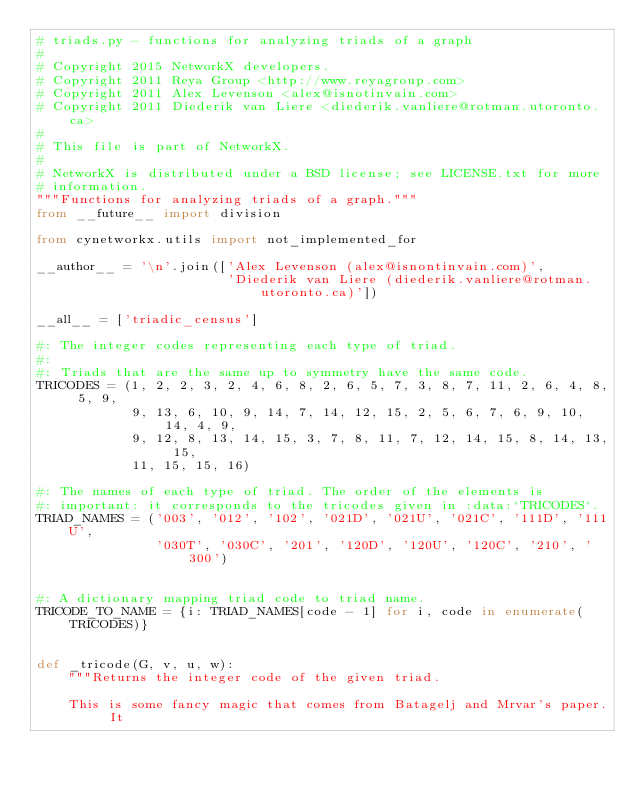<code> <loc_0><loc_0><loc_500><loc_500><_Python_># triads.py - functions for analyzing triads of a graph
#
# Copyright 2015 NetworkX developers.
# Copyright 2011 Reya Group <http://www.reyagroup.com>
# Copyright 2011 Alex Levenson <alex@isnotinvain.com>
# Copyright 2011 Diederik van Liere <diederik.vanliere@rotman.utoronto.ca>
#
# This file is part of NetworkX.
#
# NetworkX is distributed under a BSD license; see LICENSE.txt for more
# information.
"""Functions for analyzing triads of a graph."""
from __future__ import division

from cynetworkx.utils import not_implemented_for

__author__ = '\n'.join(['Alex Levenson (alex@isnontinvain.com)',
                        'Diederik van Liere (diederik.vanliere@rotman.utoronto.ca)'])

__all__ = ['triadic_census']

#: The integer codes representing each type of triad.
#:
#: Triads that are the same up to symmetry have the same code.
TRICODES = (1, 2, 2, 3, 2, 4, 6, 8, 2, 6, 5, 7, 3, 8, 7, 11, 2, 6, 4, 8, 5, 9,
            9, 13, 6, 10, 9, 14, 7, 14, 12, 15, 2, 5, 6, 7, 6, 9, 10, 14, 4, 9,
            9, 12, 8, 13, 14, 15, 3, 7, 8, 11, 7, 12, 14, 15, 8, 14, 13, 15,
            11, 15, 15, 16)

#: The names of each type of triad. The order of the elements is
#: important: it corresponds to the tricodes given in :data:`TRICODES`.
TRIAD_NAMES = ('003', '012', '102', '021D', '021U', '021C', '111D', '111U',
               '030T', '030C', '201', '120D', '120U', '120C', '210', '300')


#: A dictionary mapping triad code to triad name.
TRICODE_TO_NAME = {i: TRIAD_NAMES[code - 1] for i, code in enumerate(TRICODES)}


def _tricode(G, v, u, w):
    """Returns the integer code of the given triad.

    This is some fancy magic that comes from Batagelj and Mrvar's paper. It</code> 